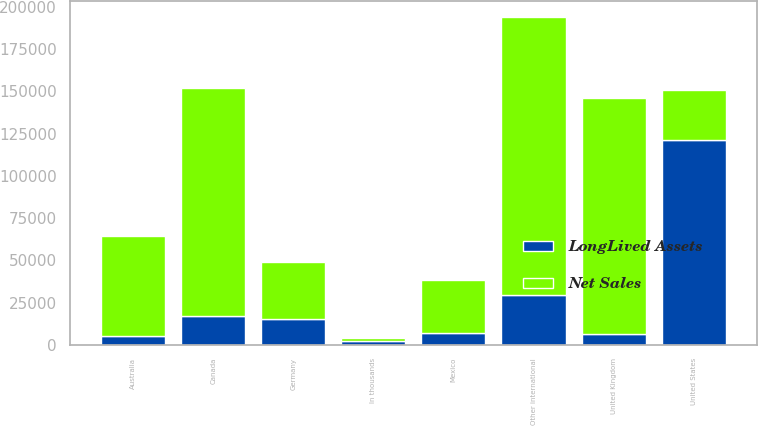Convert chart. <chart><loc_0><loc_0><loc_500><loc_500><stacked_bar_chart><ecel><fcel>In thousands<fcel>United States<fcel>Canada<fcel>Mexico<fcel>United Kingdom<fcel>Australia<fcel>Germany<fcel>Other international<nl><fcel>Net Sales<fcel>2009<fcel>29351<fcel>134811<fcel>31515<fcel>139804<fcel>59016<fcel>33478<fcel>164729<nl><fcel>LongLived Assets<fcel>2009<fcel>121427<fcel>17203<fcel>6778<fcel>6490<fcel>5216<fcel>15242<fcel>29351<nl></chart> 